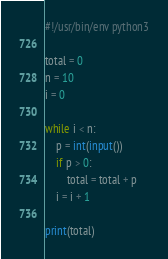Convert code to text. <code><loc_0><loc_0><loc_500><loc_500><_Python_>#!/usr/bin/env python3

total = 0
n = 10
i = 0

while i < n:
    p = int(input())
    if p > 0:
        total = total + p
    i = i + 1

print(total)
</code> 